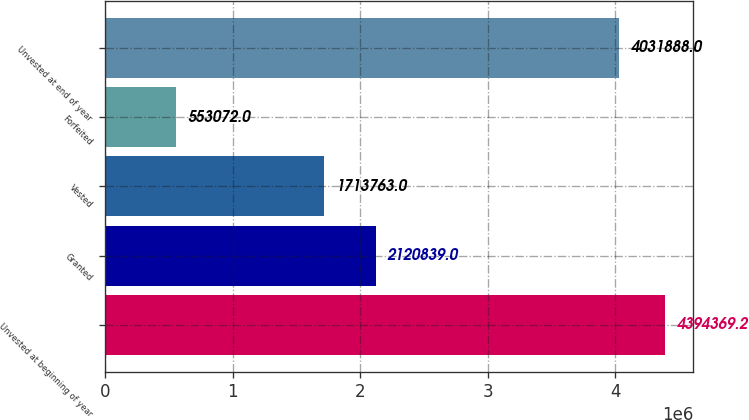Convert chart to OTSL. <chart><loc_0><loc_0><loc_500><loc_500><bar_chart><fcel>Unvested at beginning of year<fcel>Granted<fcel>Vested<fcel>Forfeited<fcel>Unvested at end of year<nl><fcel>4.39437e+06<fcel>2.12084e+06<fcel>1.71376e+06<fcel>553072<fcel>4.03189e+06<nl></chart> 